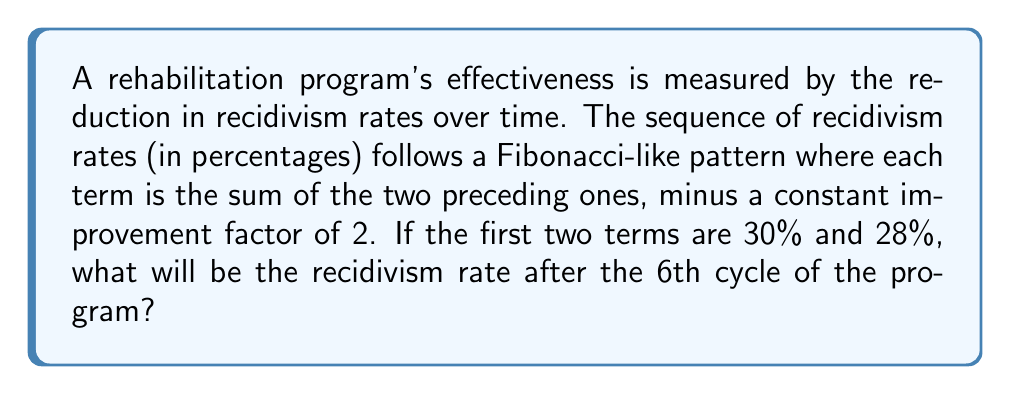Teach me how to tackle this problem. Let's approach this step-by-step:

1) We're given a Fibonacci-like sequence where each term is the sum of the two preceding ones, minus 2.

2) Let's denote the terms of the sequence as $a_n$. We're given:
   $a_1 = 30$
   $a_2 = 28$

3) The general formula for this sequence is:
   $a_n = a_{n-1} + a_{n-2} - 2$ for $n \geq 3$

4) Let's calculate each term:
   $a_3 = a_2 + a_1 - 2 = 28 + 30 - 2 = 56$
   $a_4 = a_3 + a_2 - 2 = 56 + 28 - 2 = 82$
   $a_5 = a_4 + a_3 - 2 = 82 + 56 - 2 = 136$
   $a_6 = a_5 + a_4 - 2 = 136 + 82 - 2 = 216$

5) The question asks for the 6th term, which we've calculated to be 216.

6) However, we need to remember that these are percentages. A recidivism rate of 216% doesn't make sense in reality.

7) To interpret this result, we can assume that the sequence represents the reduction in recidivism rates relative to an initial baseline.

8) If we take the initial rate (30%) as our baseline, the actual recidivism rate after the 6th cycle would be:
   $30\% - (216\% - 30\%) = 30\% - 186\% = -156\%$

9) Since negative recidivism rates are not possible, we can conclude that the program has effectively reduced recidivism to 0% by the 6th cycle.
Answer: 0% 